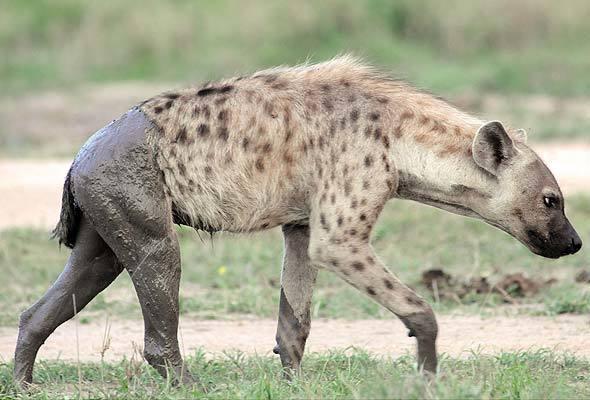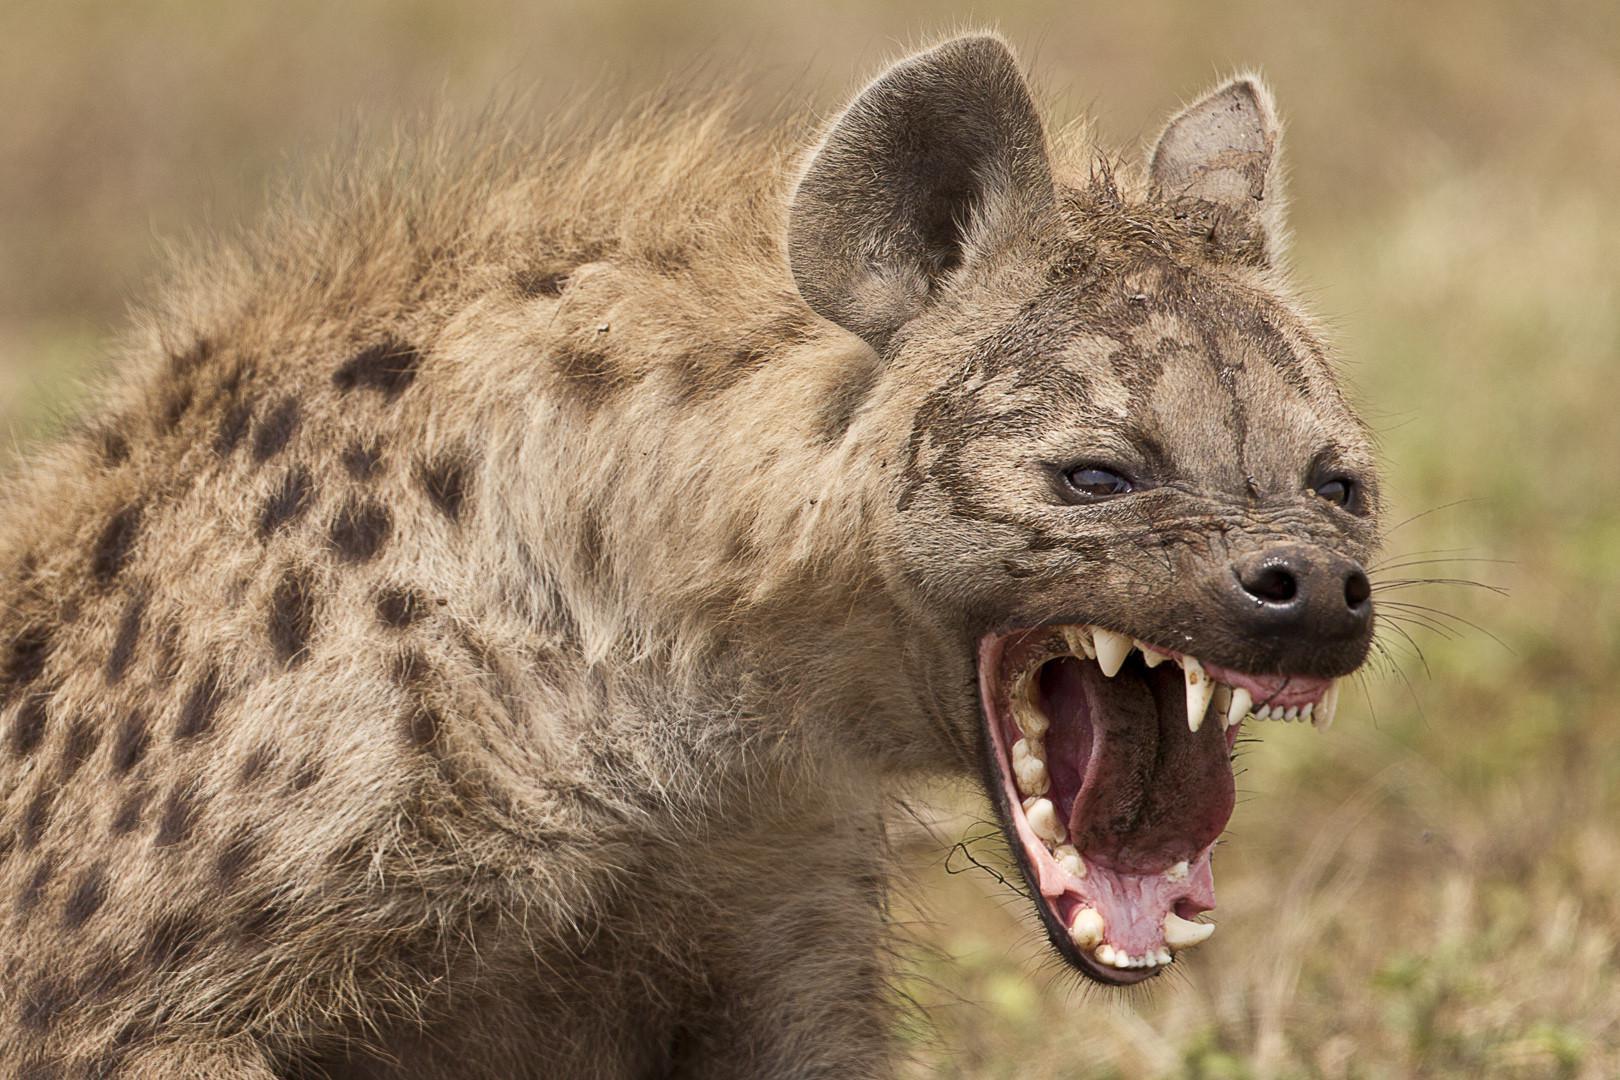The first image is the image on the left, the second image is the image on the right. Evaluate the accuracy of this statement regarding the images: "In one of the images, there is one hyena with its mouth open bearing its teeth". Is it true? Answer yes or no. Yes. 